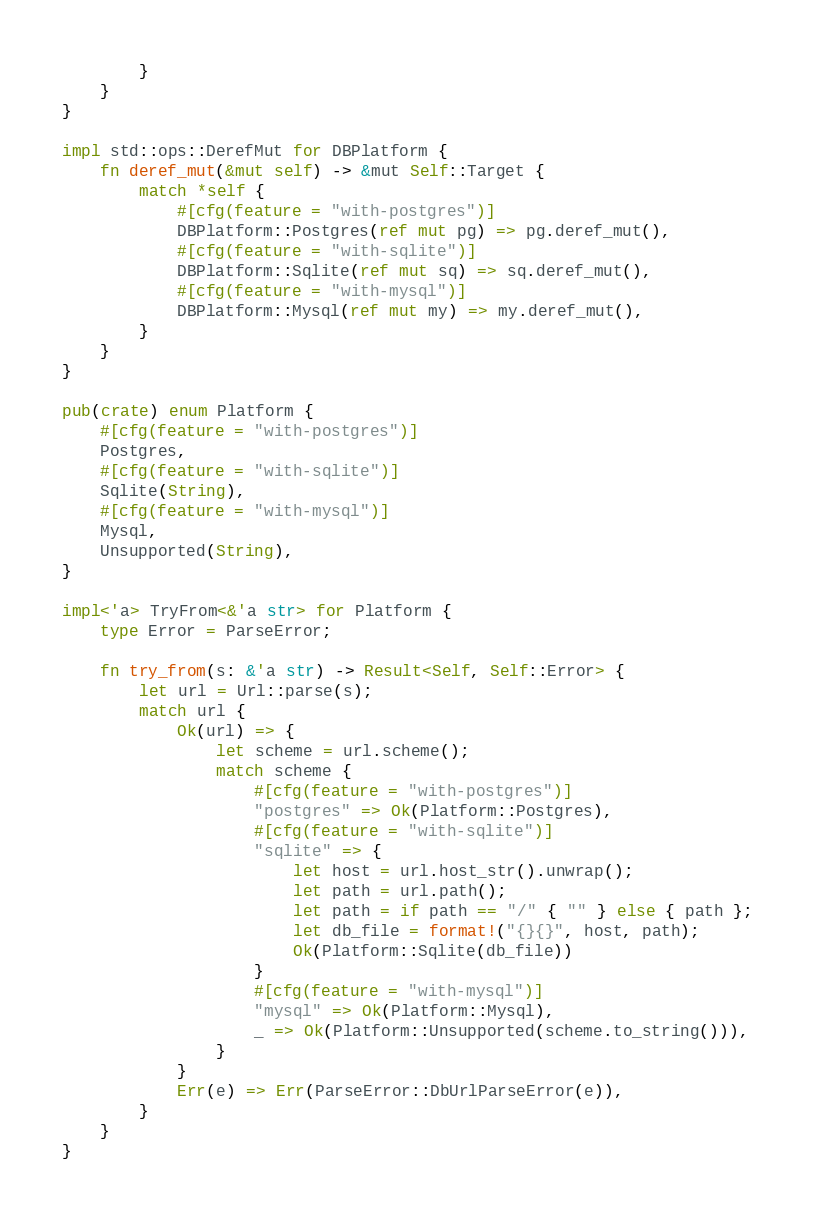<code> <loc_0><loc_0><loc_500><loc_500><_Rust_>        }
    }
}

impl std::ops::DerefMut for DBPlatform {
    fn deref_mut(&mut self) -> &mut Self::Target {
        match *self {
            #[cfg(feature = "with-postgres")]
            DBPlatform::Postgres(ref mut pg) => pg.deref_mut(),
            #[cfg(feature = "with-sqlite")]
            DBPlatform::Sqlite(ref mut sq) => sq.deref_mut(),
            #[cfg(feature = "with-mysql")]
            DBPlatform::Mysql(ref mut my) => my.deref_mut(),
        }
    }
}

pub(crate) enum Platform {
    #[cfg(feature = "with-postgres")]
    Postgres,
    #[cfg(feature = "with-sqlite")]
    Sqlite(String),
    #[cfg(feature = "with-mysql")]
    Mysql,
    Unsupported(String),
}

impl<'a> TryFrom<&'a str> for Platform {
    type Error = ParseError;

    fn try_from(s: &'a str) -> Result<Self, Self::Error> {
        let url = Url::parse(s);
        match url {
            Ok(url) => {
                let scheme = url.scheme();
                match scheme {
                    #[cfg(feature = "with-postgres")]
                    "postgres" => Ok(Platform::Postgres),
                    #[cfg(feature = "with-sqlite")]
                    "sqlite" => {
                        let host = url.host_str().unwrap();
                        let path = url.path();
                        let path = if path == "/" { "" } else { path };
                        let db_file = format!("{}{}", host, path);
                        Ok(Platform::Sqlite(db_file))
                    }
                    #[cfg(feature = "with-mysql")]
                    "mysql" => Ok(Platform::Mysql),
                    _ => Ok(Platform::Unsupported(scheme.to_string())),
                }
            }
            Err(e) => Err(ParseError::DbUrlParseError(e)),
        }
    }
}
</code> 